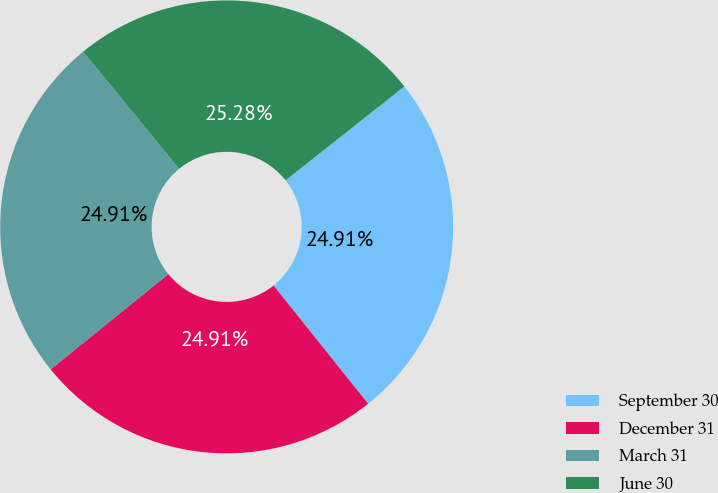<chart> <loc_0><loc_0><loc_500><loc_500><pie_chart><fcel>September 30<fcel>December 31<fcel>March 31<fcel>June 30<nl><fcel>24.91%<fcel>24.91%<fcel>24.91%<fcel>25.28%<nl></chart> 